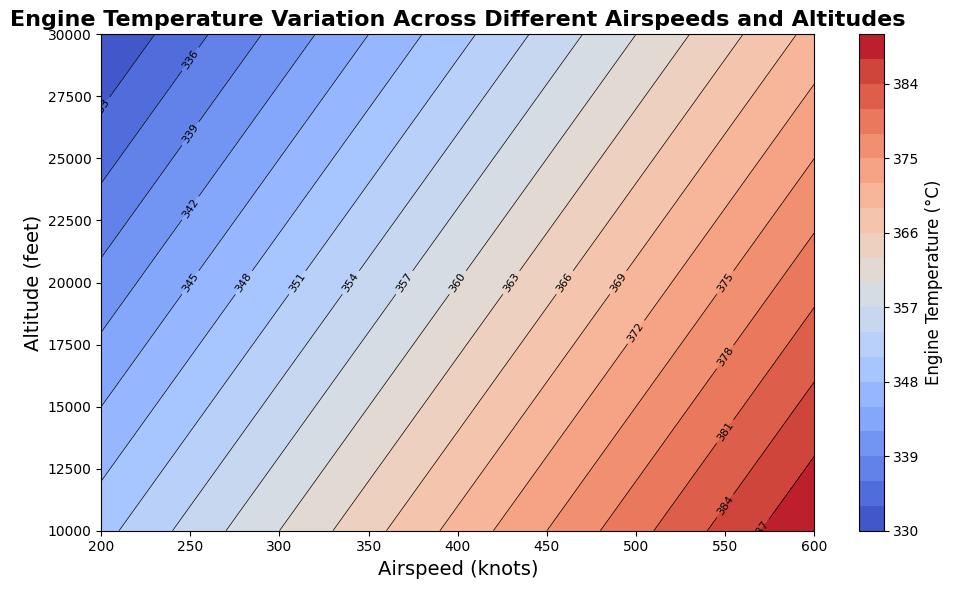What is the range of engine temperatures at an airspeed of 300 knots? At an airspeed of 300 knots, the contour plot shows engine temperatures for different altitudes. The temperatures range from 340°C at an altitude of 30,000 feet to 360°C at 10,000 feet.
Answer: 340°C to 360°C Which altitude shows the most significant temperature variation as airspeed increases from 200 to 600 knots? At 10,000 feet, the temperature increases from 350°C at an airspeed of 200 knots to 390°C at 600 knots, indicating a significant variation of 40°C.
Answer: 10,000 feet Does the engine temperature increase or decrease as altitude increases for a fixed airspeed? For a fixed airspeed, the contour lines show that the engine temperature generally decreases as the altitude increases. For example, at 200 knots, the temperature decreases from 350°C at 10,000 feet to 330°C at 30,000 feet.
Answer: Decrease What is the engine temperature at an altitude of 20,000 feet and an airspeed of 400 knots? The contour plot shows that the engine temperature at 20,000 feet and an airspeed of 400 knots is 360°C.
Answer: 360°C Compare the engine temperatures at 350 knots for 10,000 feet and 30,000 feet. At 350 knots, the temperature at 10,000 feet is 365°C, while at 30,000 feet it is 345°C. The temperature at 10,000 feet is 20°C higher than at 30,000 feet.
Answer: 20°C higher at 10,000 feet Which airspeed yields a temperature of 355°C at 10,000 feet? The contour plot shows that at 10,000 feet, a temperature of 355°C is observed at an airspeed of 250 knots.
Answer: 250 knots Is there a consistent pattern in temperature change with varying altitudes across different airspeeds? Yes, the temperature consistently decreases as altitude increases across all airspeeds. For instance, at all airspeeds from 200 to 600 knots, the temperature is higher at 10,000 feet and lower at 30,000 feet.
Answer: Yes Calculate the average engine temperature at 450 knots across all altitudes. At 450 knots, the temperatures are 375°C (10,000 feet), 365°C (20,000 feet), and 355°C (30,000 feet). The average is (375 + 365 + 355) / 3 = 365°C.
Answer: 365°C 